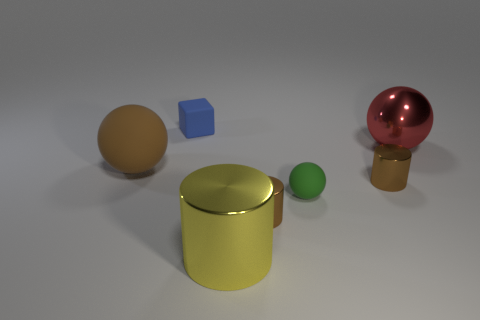Is there a metallic cylinder of the same color as the big metal ball? No, the cylinder present in the image is not of the same color as the big metal ball. The cylinder appears to have a golden hue, while the large metal ball has a distinctly different color, which is a reflective pinkish-red. 